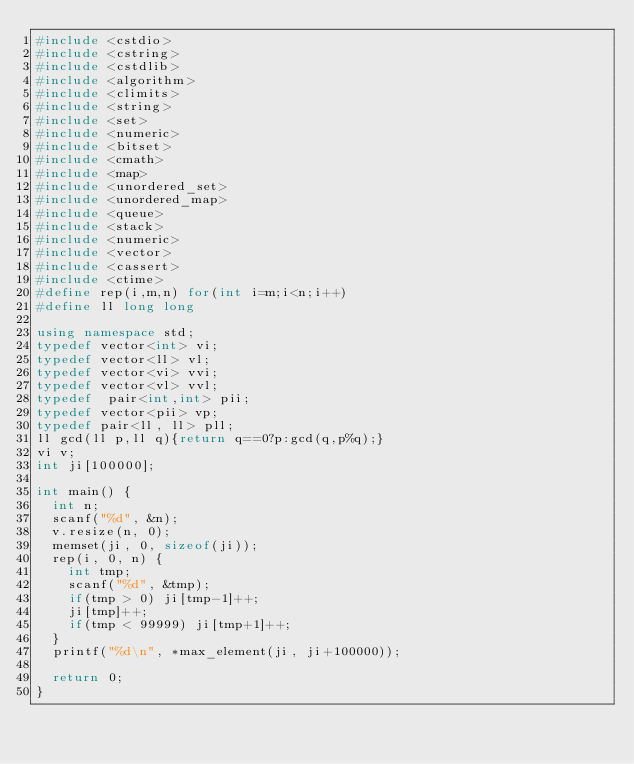Convert code to text. <code><loc_0><loc_0><loc_500><loc_500><_C++_>#include <cstdio>
#include <cstring>
#include <cstdlib>
#include <algorithm>
#include <climits>
#include <string>
#include <set>
#include <numeric>
#include <bitset>
#include <cmath>
#include <map>
#include <unordered_set>
#include <unordered_map>
#include <queue>
#include <stack>
#include <numeric>
#include <vector>
#include <cassert>
#include <ctime>
#define rep(i,m,n) for(int i=m;i<n;i++)
#define ll long long

using namespace std;
typedef vector<int> vi;
typedef vector<ll> vl;
typedef vector<vi> vvi;
typedef vector<vl> vvl;
typedef  pair<int,int> pii;
typedef vector<pii> vp;
typedef pair<ll, ll> pll;
ll gcd(ll p,ll q){return q==0?p:gcd(q,p%q);}
vi v;
int ji[100000];

int main() {
	int n;
	scanf("%d", &n);
	v.resize(n, 0);
	memset(ji, 0, sizeof(ji));
	rep(i, 0, n) {
		int tmp;
		scanf("%d", &tmp);
		if(tmp > 0) ji[tmp-1]++;
		ji[tmp]++;
		if(tmp < 99999) ji[tmp+1]++;
	}
	printf("%d\n", *max_element(ji, ji+100000));

	return 0;
}
</code> 